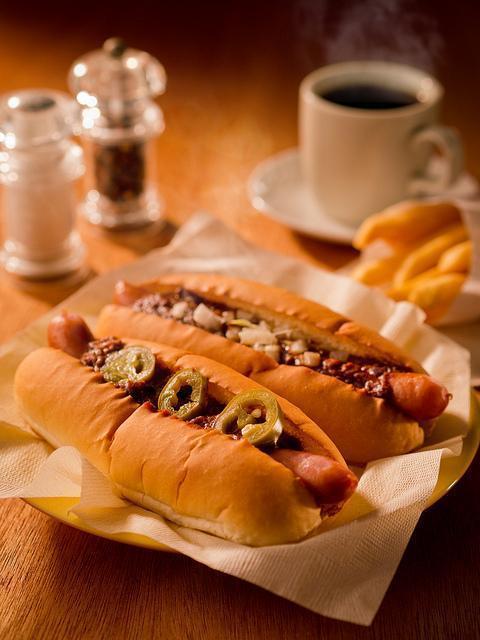How many hot dogs are there?
Give a very brief answer. 2. How many train cars are pictured?
Give a very brief answer. 0. 